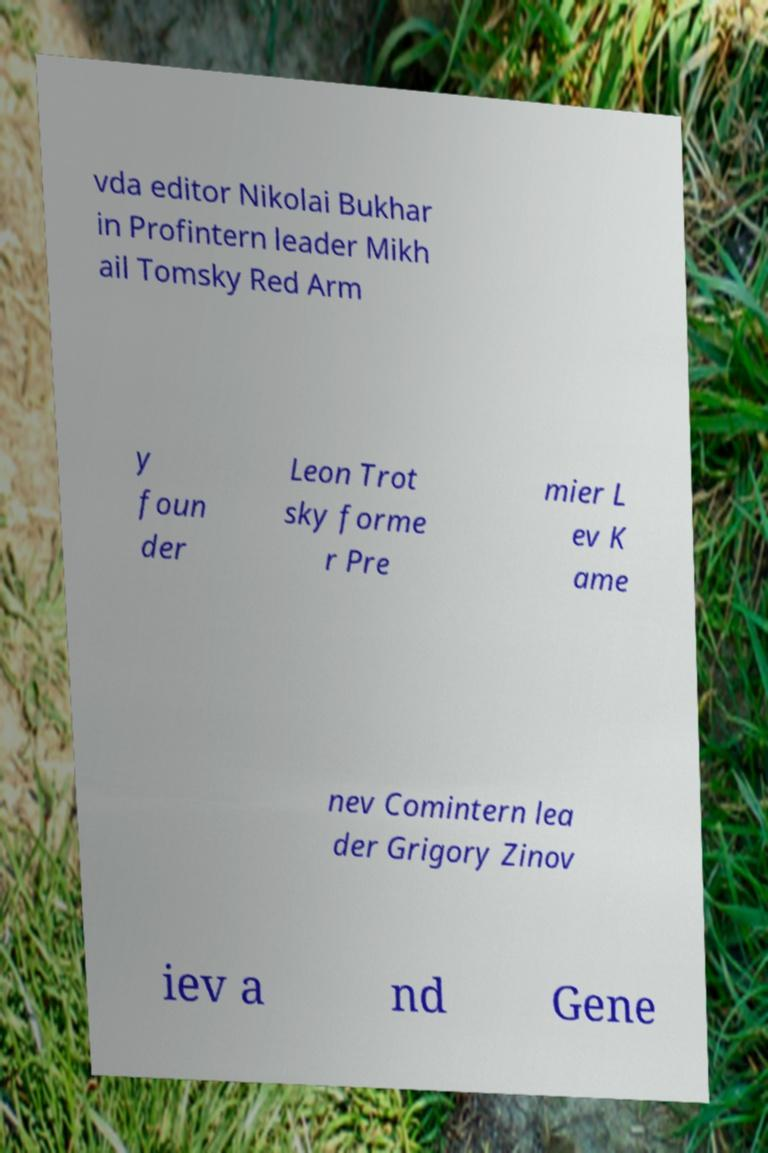Could you extract and type out the text from this image? vda editor Nikolai Bukhar in Profintern leader Mikh ail Tomsky Red Arm y foun der Leon Trot sky forme r Pre mier L ev K ame nev Comintern lea der Grigory Zinov iev a nd Gene 